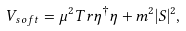Convert formula to latex. <formula><loc_0><loc_0><loc_500><loc_500>V _ { s o f t } = \mu ^ { 2 } T r \eta ^ { \dagger } \eta + m ^ { 2 } | S | ^ { 2 } ,</formula> 